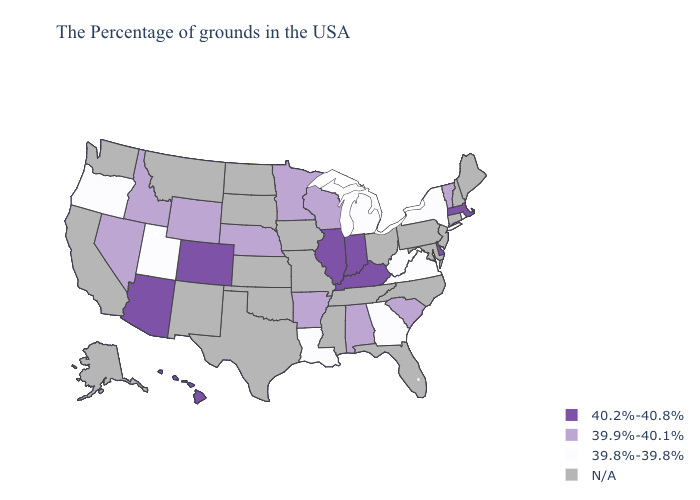Name the states that have a value in the range 40.2%-40.8%?
Short answer required. Massachusetts, Delaware, Kentucky, Indiana, Illinois, Colorado, Arizona, Hawaii. What is the value of Indiana?
Write a very short answer. 40.2%-40.8%. What is the highest value in the South ?
Keep it brief. 40.2%-40.8%. What is the value of Georgia?
Answer briefly. 39.8%-39.8%. Among the states that border Washington , does Idaho have the highest value?
Concise answer only. Yes. Does the first symbol in the legend represent the smallest category?
Write a very short answer. No. Does the first symbol in the legend represent the smallest category?
Keep it brief. No. Does the map have missing data?
Concise answer only. Yes. Name the states that have a value in the range 40.2%-40.8%?
Quick response, please. Massachusetts, Delaware, Kentucky, Indiana, Illinois, Colorado, Arizona, Hawaii. Name the states that have a value in the range 40.2%-40.8%?
Concise answer only. Massachusetts, Delaware, Kentucky, Indiana, Illinois, Colorado, Arizona, Hawaii. Does the map have missing data?
Answer briefly. Yes. Does Vermont have the highest value in the USA?
Write a very short answer. No. What is the highest value in the USA?
Keep it brief. 40.2%-40.8%. 